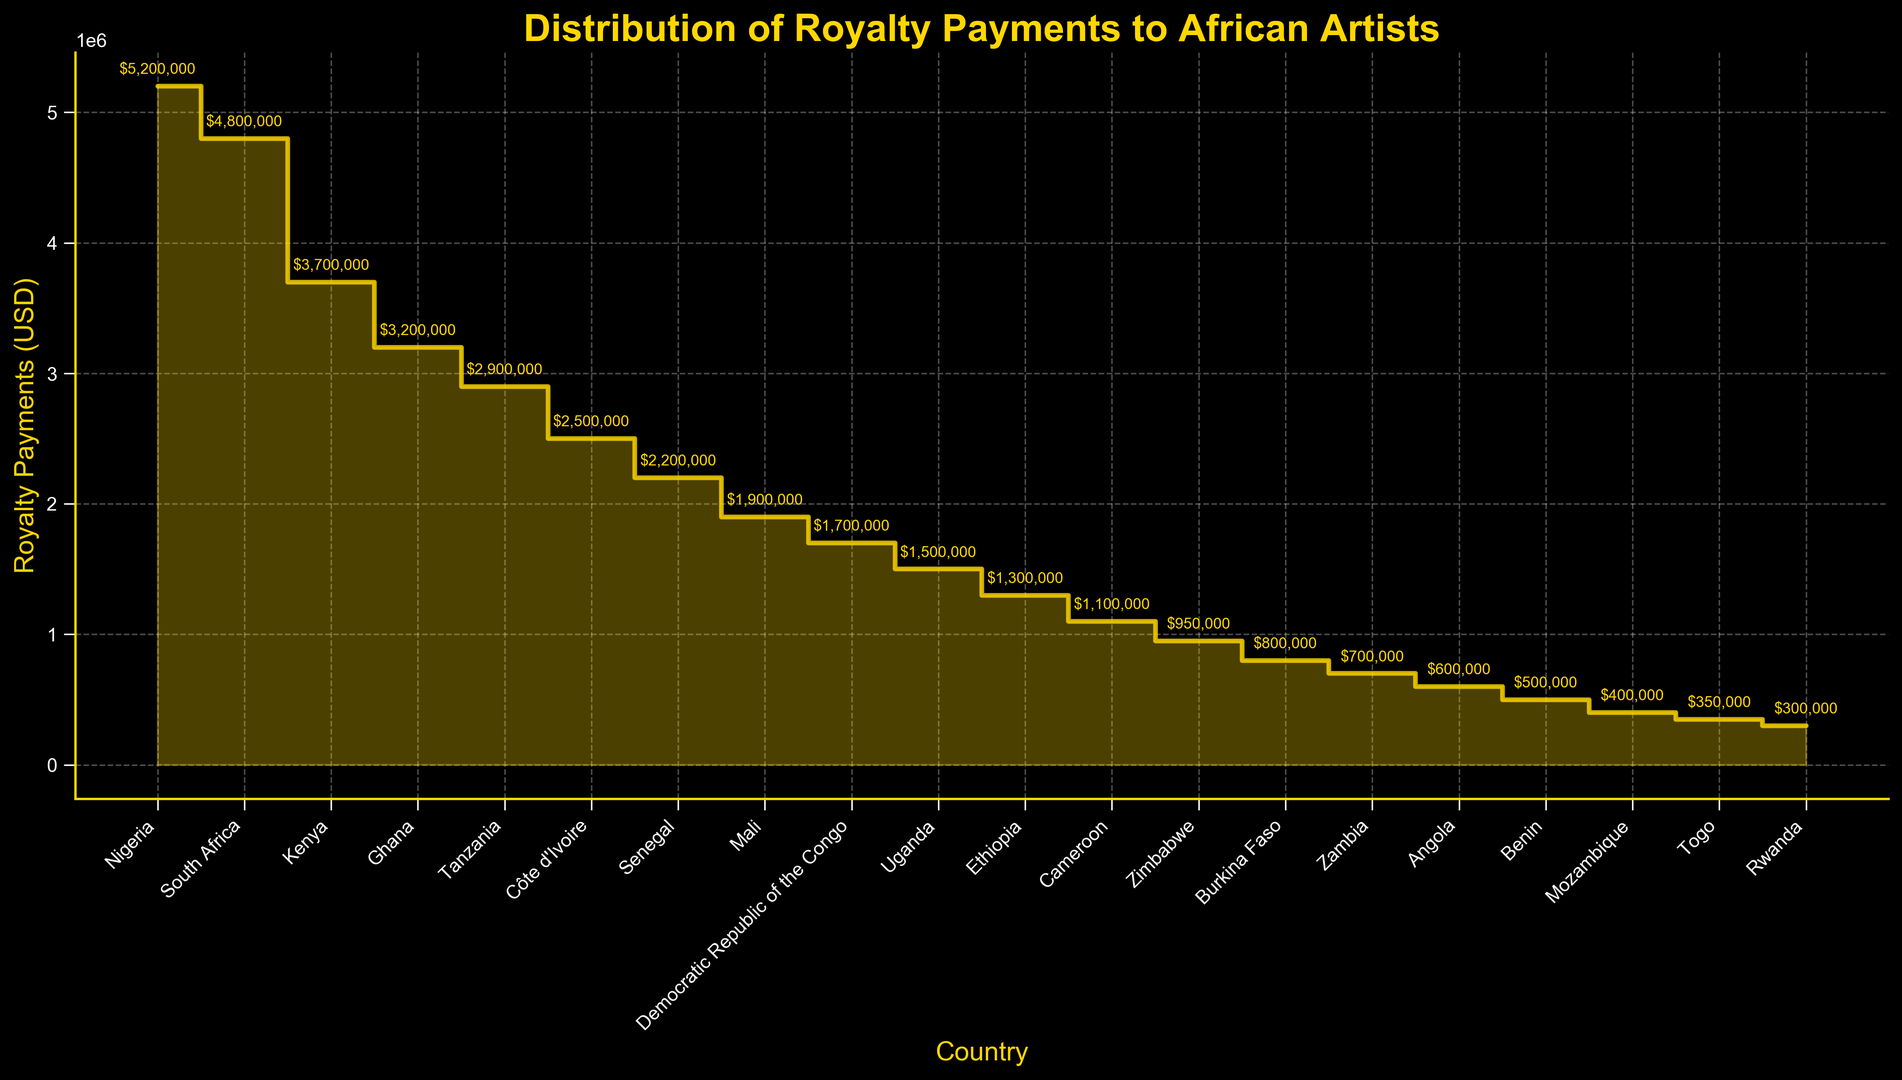What is the country with the highest royalty payments? The country with the highest bar represents the one with the highest royalty payments. The figure shows Nigeria has the highest royalty payments.
Answer: Nigeria How much more royalty payments did South Africa generate compared to Ghana? South Africa has royalty payments of $4,800,000 and Ghana has $3,200,000. The difference is calculated by $4,800,000 - $3,200,000.
Answer: $1,600,000 Which country received less royalty payments than Ethiopia, but more than Zimbabwe? Ethiopia has $1,300,000 in royalty payments and Zimbabwe has $950,000. The figure shows Cameroon with $1,100,000 fits this range.
Answer: Cameroon What is the combined royalty payment of Nigeria, South Africa, and Kenya? Nigeria has $5,200,000, South Africa $4,800,000, and Kenya $3,700,000. Adding them together gives $5,200,000 + $4,800,000 + $3,700,000.
Answer: $13,700,000 Which country received half as much royalty payments as Ghana? Ghana has $3,200,000 in royalty payments. Half of this amount is $3,200,000 / 2. The figure shows Côte d'Ivoire with $2,500,000 which is closest but not exact. No exact match exists.
Answer: N/A What is the average royalty payment of the top 5 countries? The top 5 countries are Nigeria, South Africa, Kenya, Ghana, and Tanzania. Their payments are $5,200,000, $4,800,000, $3,700,000, $3,200,000, and $2,900,000. Adding these gives $19,800,000, then divide by 5.
Answer: $3,960,000 How much in royalties did Uganda collect more than Mozambique? Uganda has $1,500,000 in royalties compared to Mozambique's $400,000. The difference is $1,500,000 - $400,000.
Answer: $1,100,000 Between Zambia and Burkina Faso, which country received more in royalties? Zambia has $700,000 and Burkina Faso has $800,000. Burkina Faso has the higher amount.
Answer: Burkina Faso What is the total royalty payment for the bottom 3 countries in the list? The bottom 3 countries are Mozambique, Togo, and Rwanda. Their payments are $400,000, $350,000, and $300,000. The sum is $400,000 + $350,000 + $300,000.
Answer: $1,050,000 What is the visual difference between the royalty payments of Cameroon and Zimbabwe in terms of height on the plot? Cameroon has $1,100,000 and Zimbabwe has $950,000. The visual height difference corresponds to $1,100,000 - $950,000. The plotted bars will show Cameroon slightly higher than Zimbabwe.
Answer: $150,000 